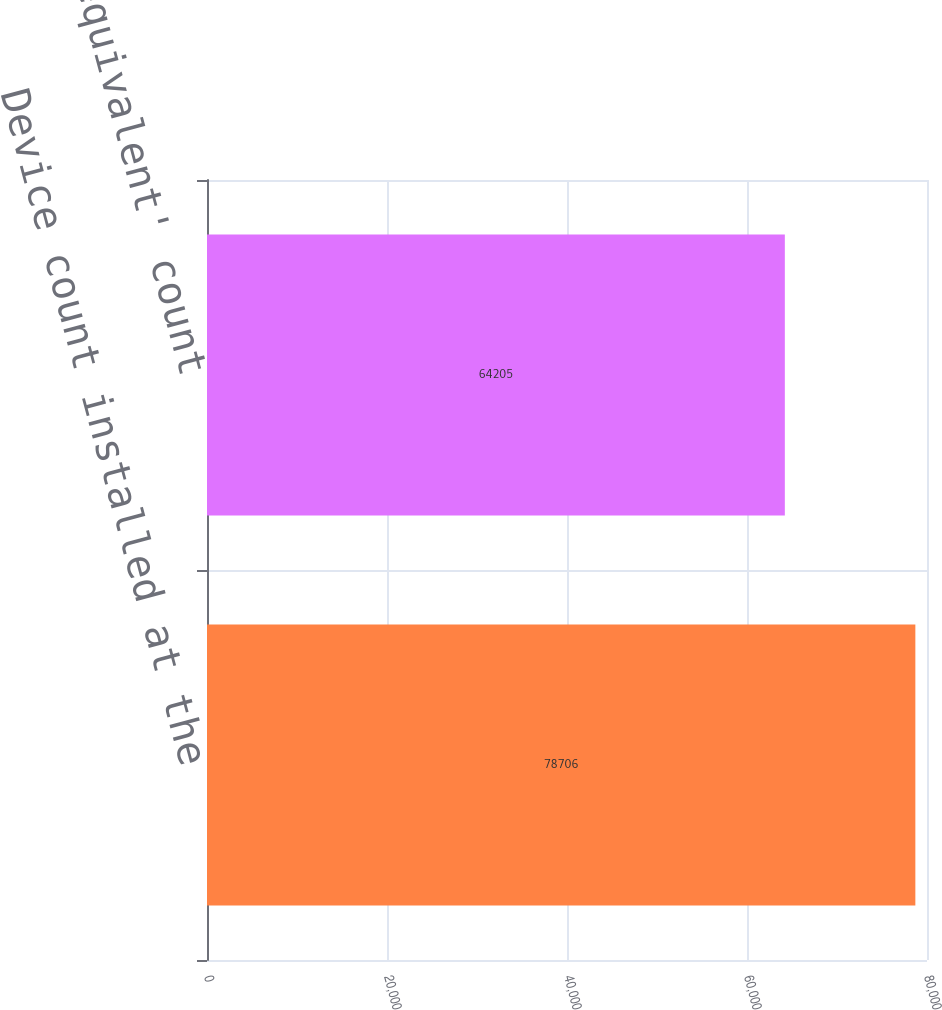Convert chart. <chart><loc_0><loc_0><loc_500><loc_500><bar_chart><fcel>Device count installed at the<fcel>'Machine equivalent' count<nl><fcel>78706<fcel>64205<nl></chart> 